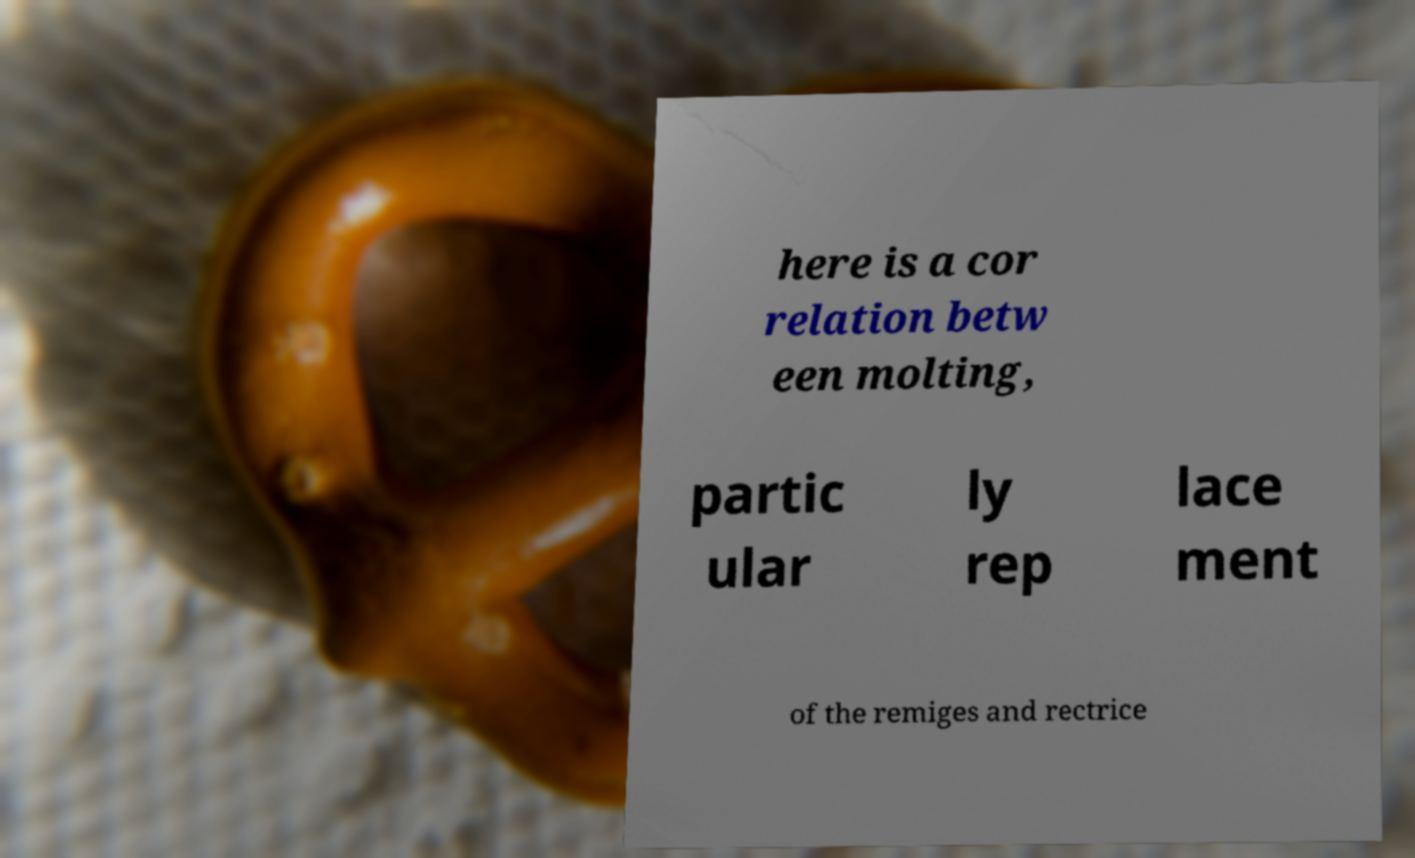For documentation purposes, I need the text within this image transcribed. Could you provide that? here is a cor relation betw een molting, partic ular ly rep lace ment of the remiges and rectrice 